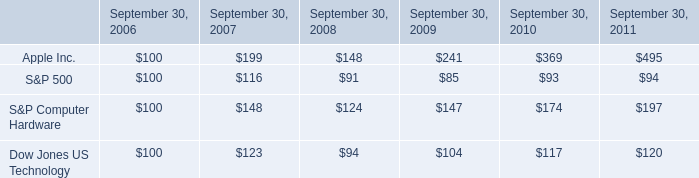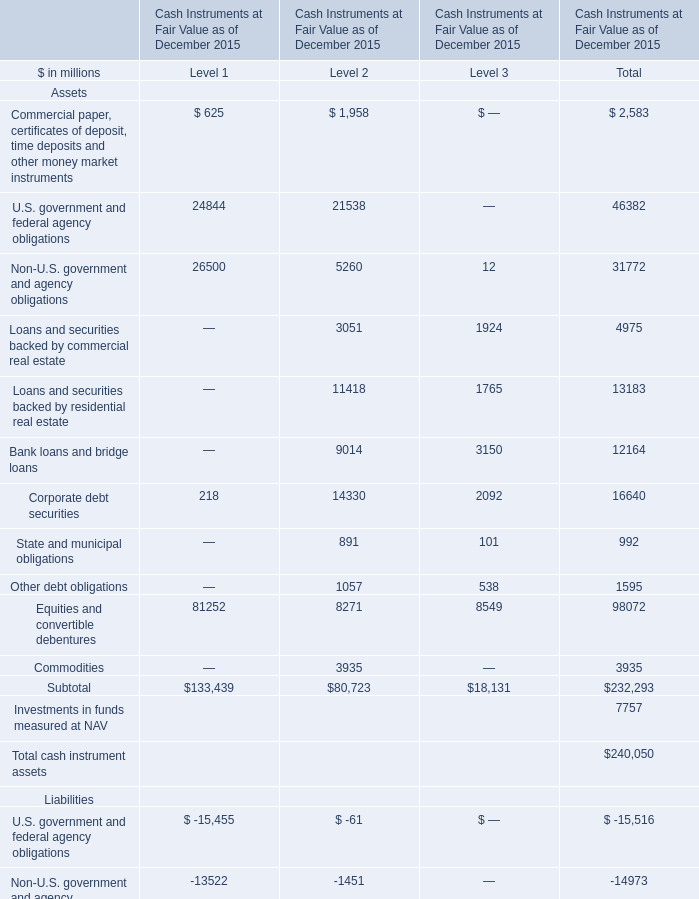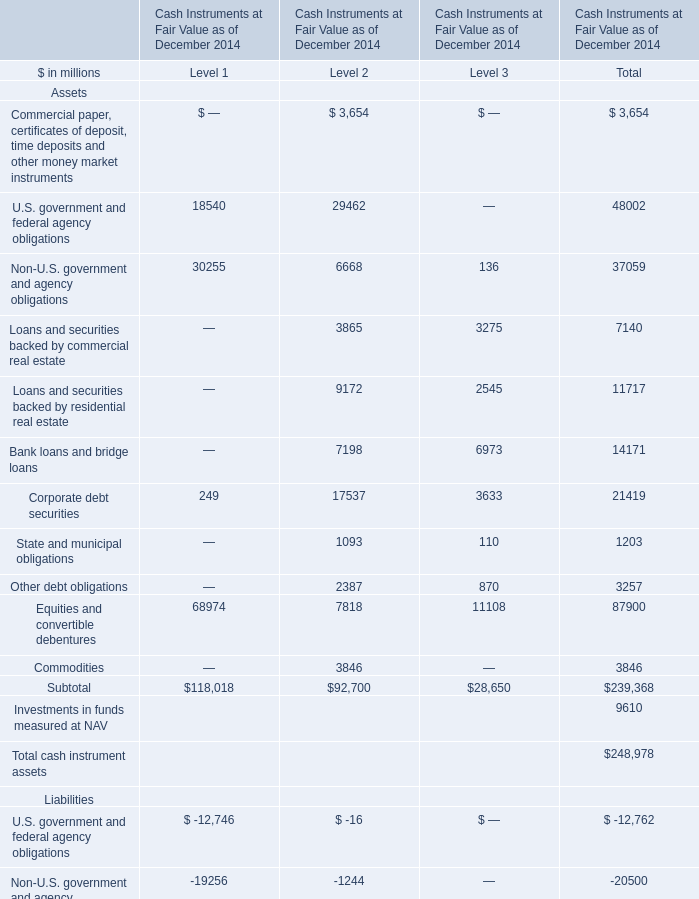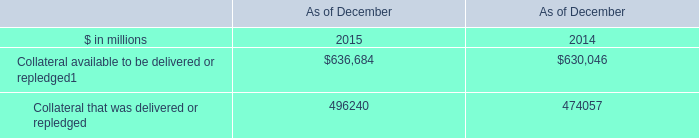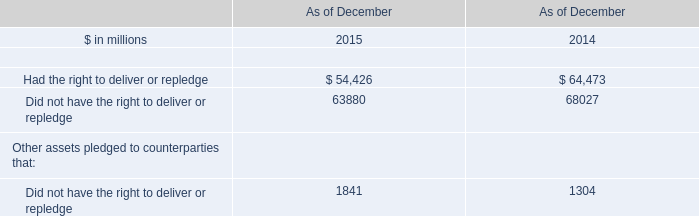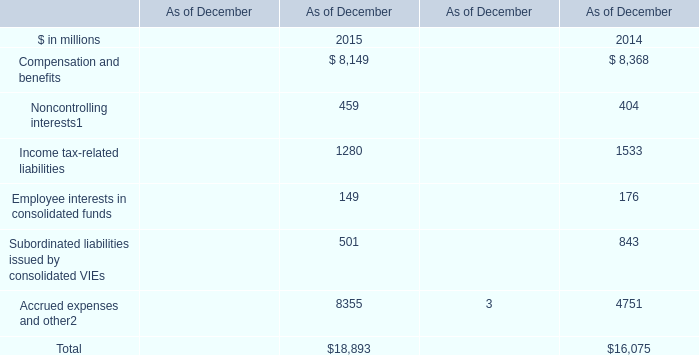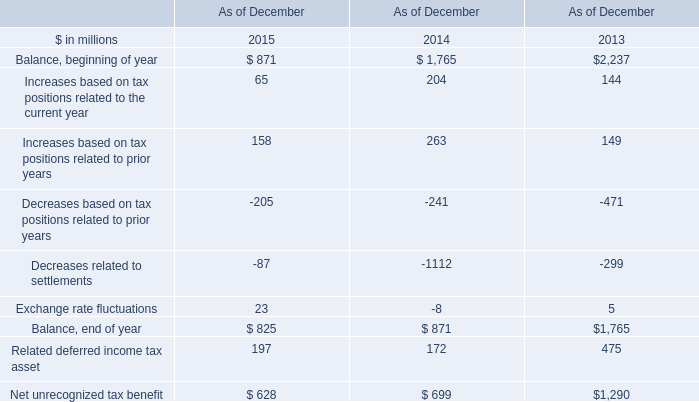In which section the sum of Equities and convertible debentures of Assets has the highest value? 
Answer: Level 1. 